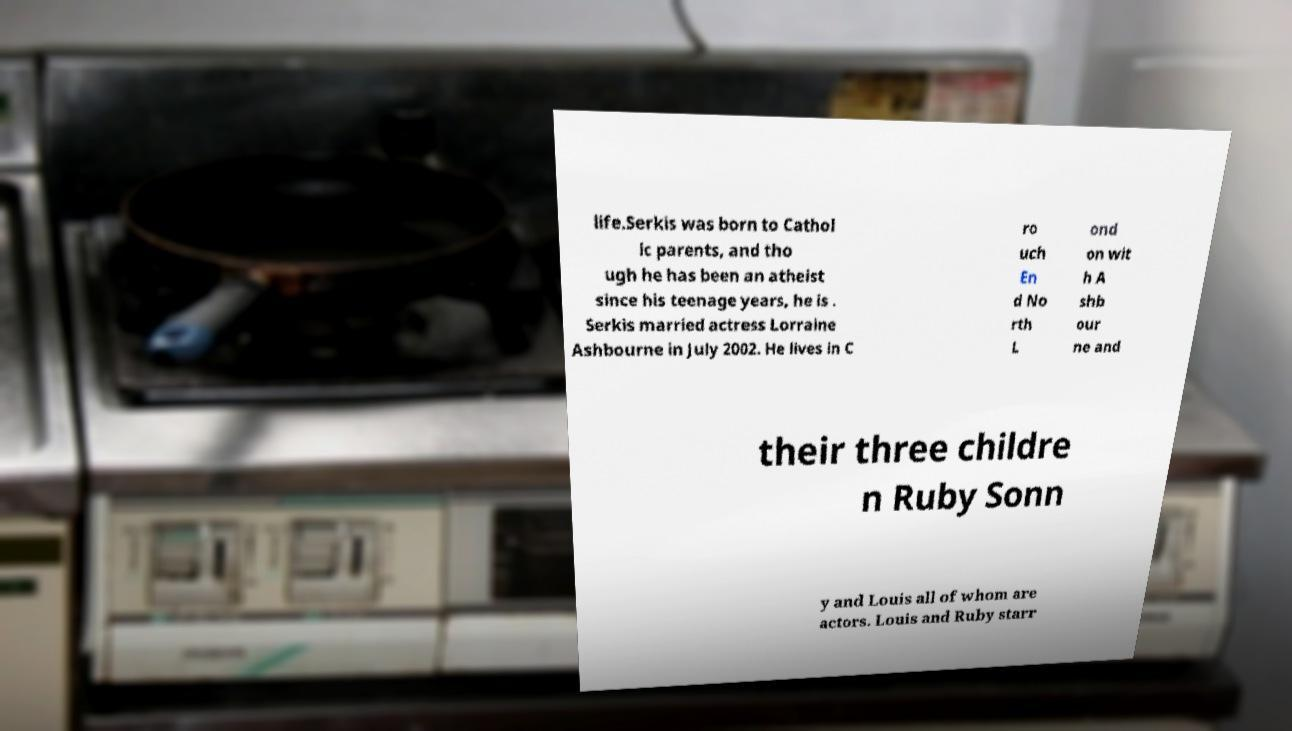For documentation purposes, I need the text within this image transcribed. Could you provide that? life.Serkis was born to Cathol ic parents, and tho ugh he has been an atheist since his teenage years, he is . Serkis married actress Lorraine Ashbourne in July 2002. He lives in C ro uch En d No rth L ond on wit h A shb our ne and their three childre n Ruby Sonn y and Louis all of whom are actors. Louis and Ruby starr 